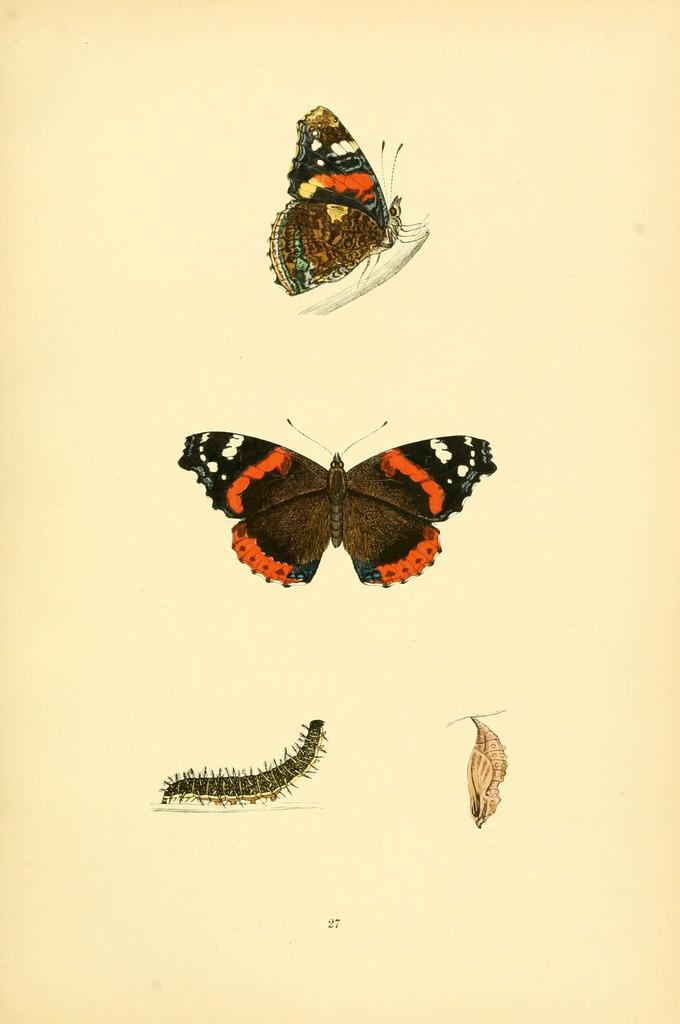What is depicted on the paper in the image? There is a drawing of insects on the paper. What colors are used in the drawing of insects? The insects are in red, black, brown, and white colors. What type of clam can be seen holding a truck on the branch in the image? There is no clam, truck, or branch present in the image; it features a drawing of insects on paper. 